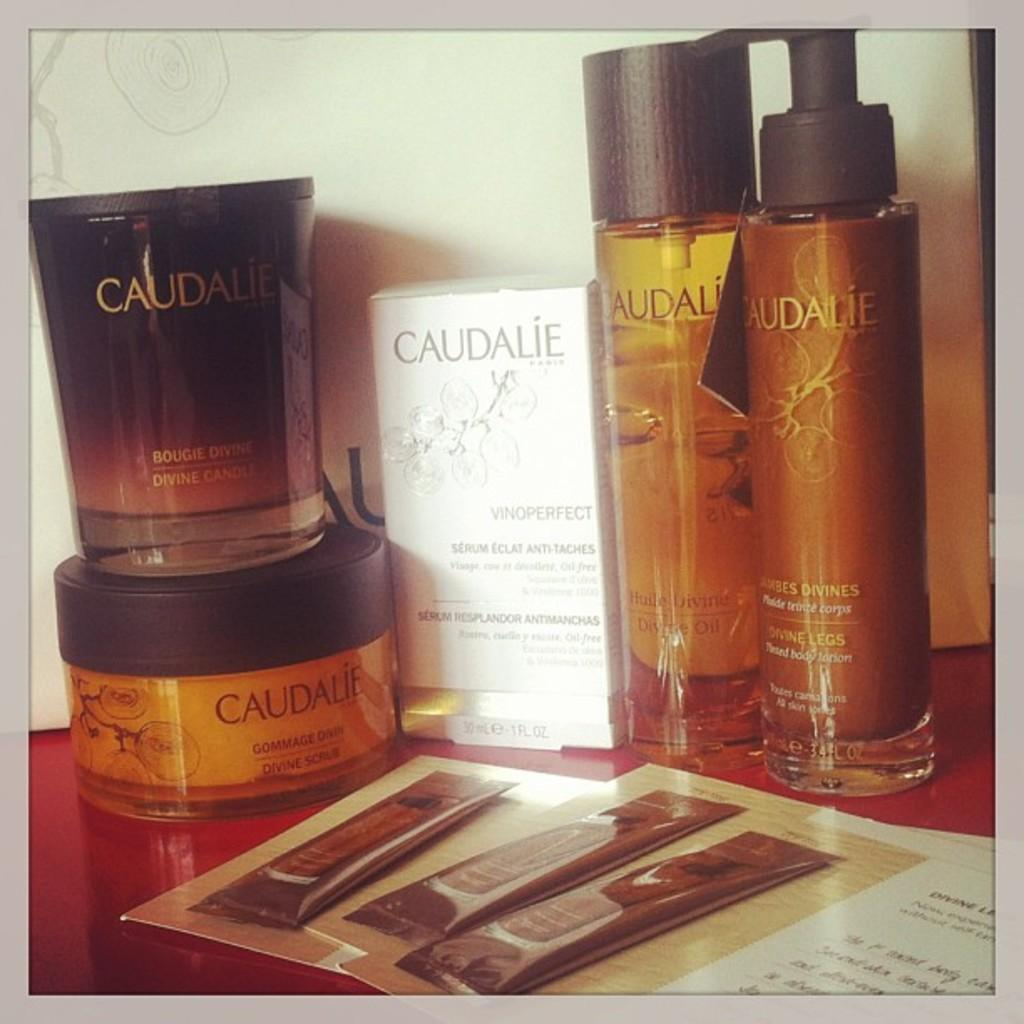<image>
Present a compact description of the photo's key features. some beauty products which have the labels caudalie 